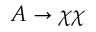Convert formula to latex. <formula><loc_0><loc_0><loc_500><loc_500>A \to \chi \chi</formula> 